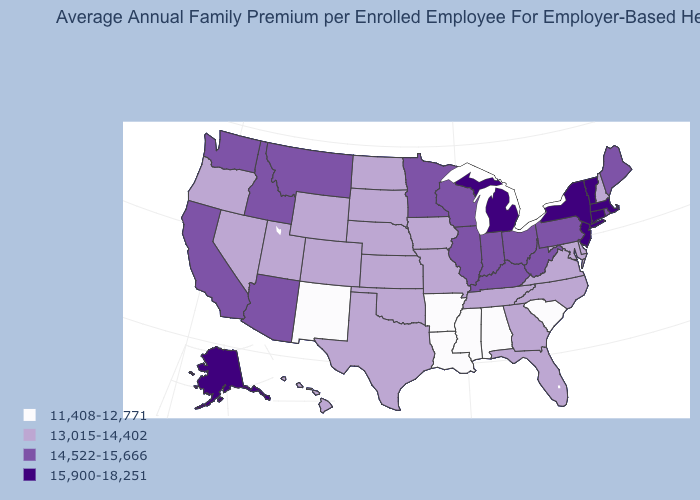Name the states that have a value in the range 13,015-14,402?
Give a very brief answer. Colorado, Delaware, Florida, Georgia, Hawaii, Iowa, Kansas, Maryland, Missouri, Nebraska, Nevada, New Hampshire, North Carolina, North Dakota, Oklahoma, Oregon, South Dakota, Tennessee, Texas, Utah, Virginia, Wyoming. Which states have the lowest value in the USA?
Quick response, please. Alabama, Arkansas, Louisiana, Mississippi, New Mexico, South Carolina. Is the legend a continuous bar?
Short answer required. No. Does Hawaii have the lowest value in the West?
Answer briefly. No. Does the map have missing data?
Be succinct. No. Name the states that have a value in the range 13,015-14,402?
Be succinct. Colorado, Delaware, Florida, Georgia, Hawaii, Iowa, Kansas, Maryland, Missouri, Nebraska, Nevada, New Hampshire, North Carolina, North Dakota, Oklahoma, Oregon, South Dakota, Tennessee, Texas, Utah, Virginia, Wyoming. What is the value of Washington?
Keep it brief. 14,522-15,666. Among the states that border Tennessee , does North Carolina have the lowest value?
Concise answer only. No. Does the map have missing data?
Write a very short answer. No. Is the legend a continuous bar?
Concise answer only. No. Name the states that have a value in the range 15,900-18,251?
Quick response, please. Alaska, Connecticut, Massachusetts, Michigan, New Jersey, New York, Vermont. Is the legend a continuous bar?
Write a very short answer. No. Name the states that have a value in the range 14,522-15,666?
Answer briefly. Arizona, California, Idaho, Illinois, Indiana, Kentucky, Maine, Minnesota, Montana, Ohio, Pennsylvania, Rhode Island, Washington, West Virginia, Wisconsin. Does Vermont have the highest value in the USA?
Quick response, please. Yes. Does Alaska have a lower value than Kansas?
Answer briefly. No. 